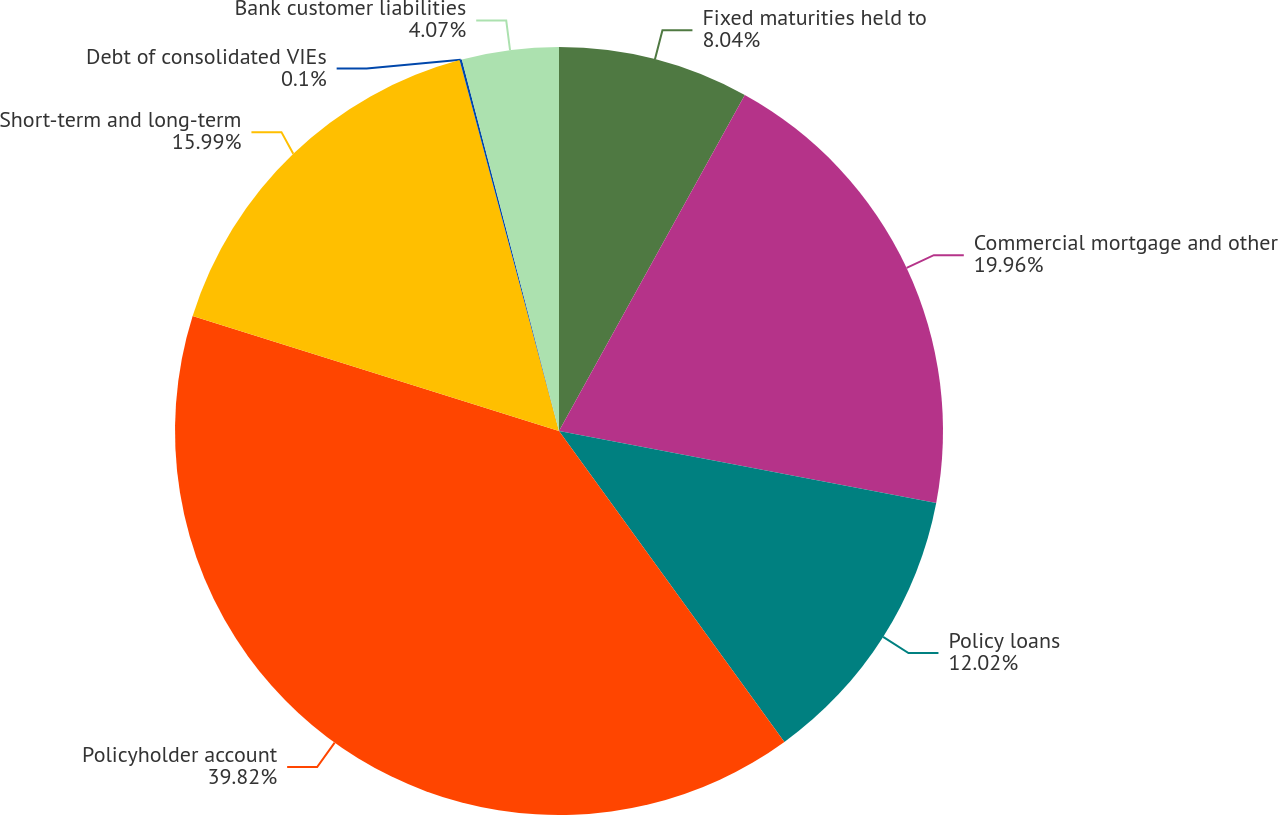<chart> <loc_0><loc_0><loc_500><loc_500><pie_chart><fcel>Fixed maturities held to<fcel>Commercial mortgage and other<fcel>Policy loans<fcel>Policyholder account<fcel>Short-term and long-term<fcel>Debt of consolidated VIEs<fcel>Bank customer liabilities<nl><fcel>8.04%<fcel>19.96%<fcel>12.02%<fcel>39.83%<fcel>15.99%<fcel>0.1%<fcel>4.07%<nl></chart> 